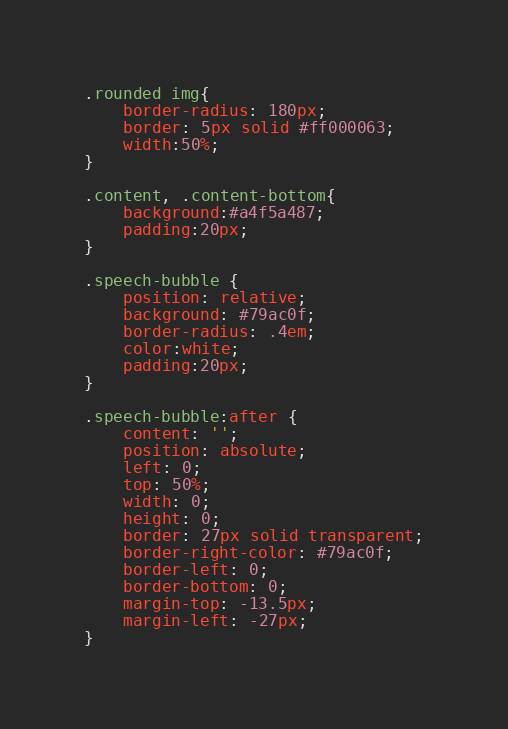Convert code to text. <code><loc_0><loc_0><loc_500><loc_500><_CSS_>.rounded img{
    border-radius: 180px;
    border: 5px solid #ff000063;
    width:50%;
}

.content, .content-bottom{
    background:#a4f5a487;
    padding:20px;
}

.speech-bubble {
	position: relative;
	background: #79ac0f;
	border-radius: .4em;
	color:white;
	padding:20px;
}

.speech-bubble:after {
	content: '';
	position: absolute;
	left: 0;
	top: 50%;
	width: 0;
	height: 0;
	border: 27px solid transparent;
	border-right-color: #79ac0f;
	border-left: 0;
	border-bottom: 0;
	margin-top: -13.5px;
	margin-left: -27px;
}
</code> 